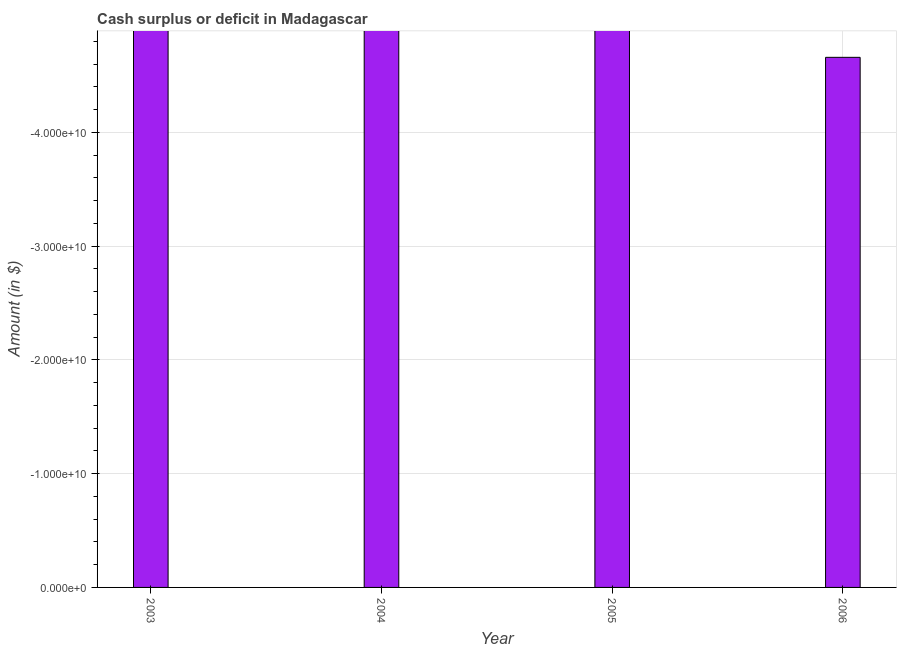Does the graph contain any zero values?
Your response must be concise. Yes. Does the graph contain grids?
Ensure brevity in your answer.  Yes. What is the title of the graph?
Make the answer very short. Cash surplus or deficit in Madagascar. What is the label or title of the X-axis?
Keep it short and to the point. Year. What is the label or title of the Y-axis?
Give a very brief answer. Amount (in $). What is the cash surplus or deficit in 2006?
Provide a succinct answer. 0. What is the average cash surplus or deficit per year?
Provide a short and direct response. 0. What is the median cash surplus or deficit?
Your answer should be compact. 0. How many bars are there?
Your response must be concise. 0. What is the difference between two consecutive major ticks on the Y-axis?
Offer a terse response. 1.00e+1. What is the Amount (in $) in 2005?
Offer a terse response. 0. What is the Amount (in $) in 2006?
Offer a terse response. 0. 